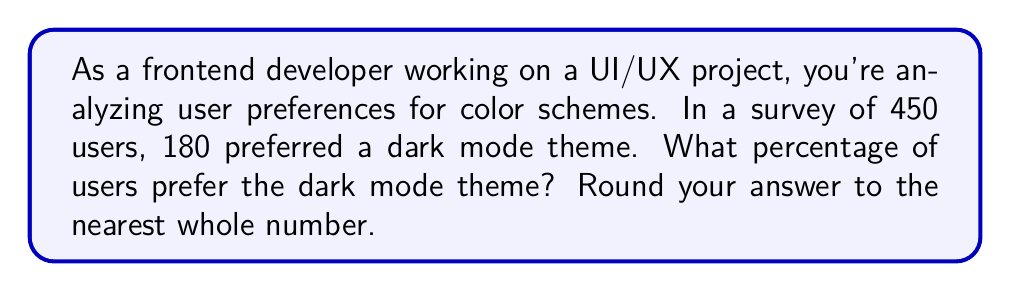Give your solution to this math problem. To solve this problem, we need to follow these steps:

1. Identify the total number of users surveyed and the number who prefer dark mode:
   - Total users: 450
   - Users preferring dark mode: 180

2. Calculate the percentage using the formula:
   $$ \text{Percentage} = \frac{\text{Number of users preferring dark mode}}{\text{Total number of users}} \times 100 $$

3. Plug in the values:
   $$ \text{Percentage} = \frac{180}{450} \times 100 $$

4. Simplify the fraction:
   $$ \text{Percentage} = \frac{2}{5} \times 100 $$

5. Perform the multiplication:
   $$ \text{Percentage} = 0.4 \times 100 = 40 $$

6. Round to the nearest whole number:
   The result is already a whole number, so no rounding is necessary.

Therefore, 40% of users prefer the dark mode theme.
Answer: 40% 